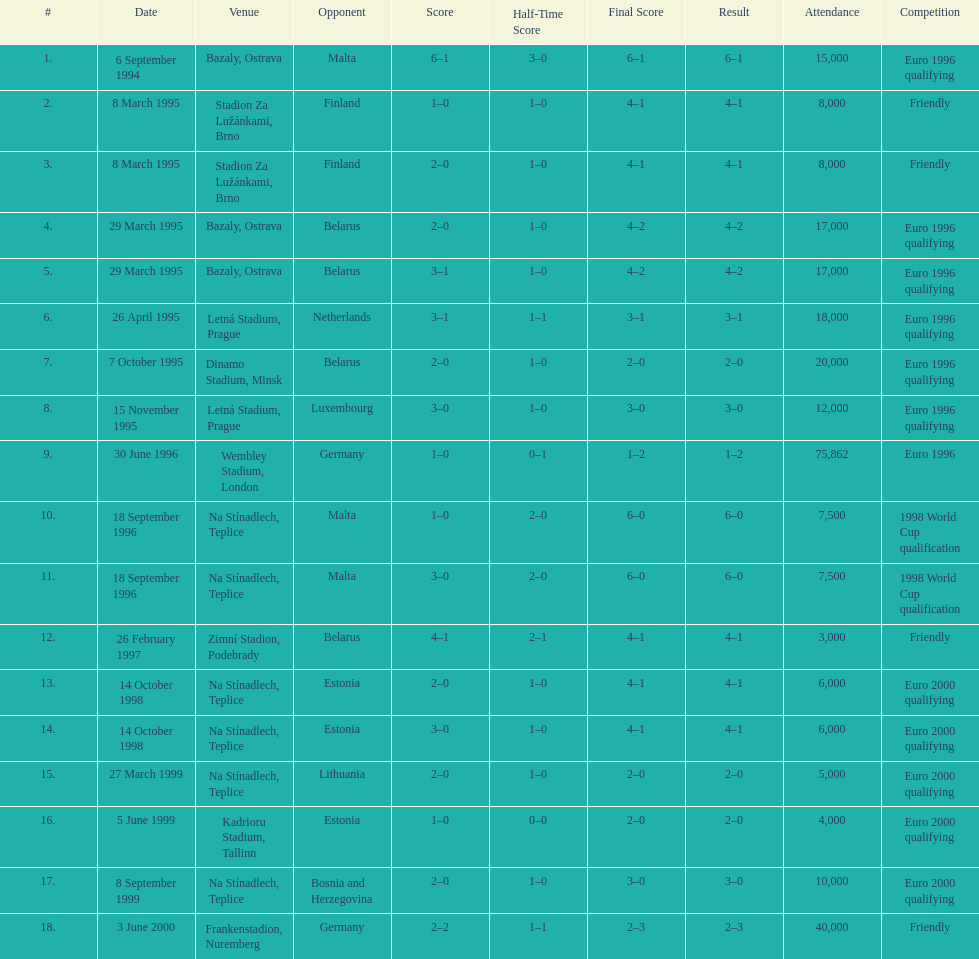List the opponents which are under the friendly competition. Finland, Belarus, Germany. 